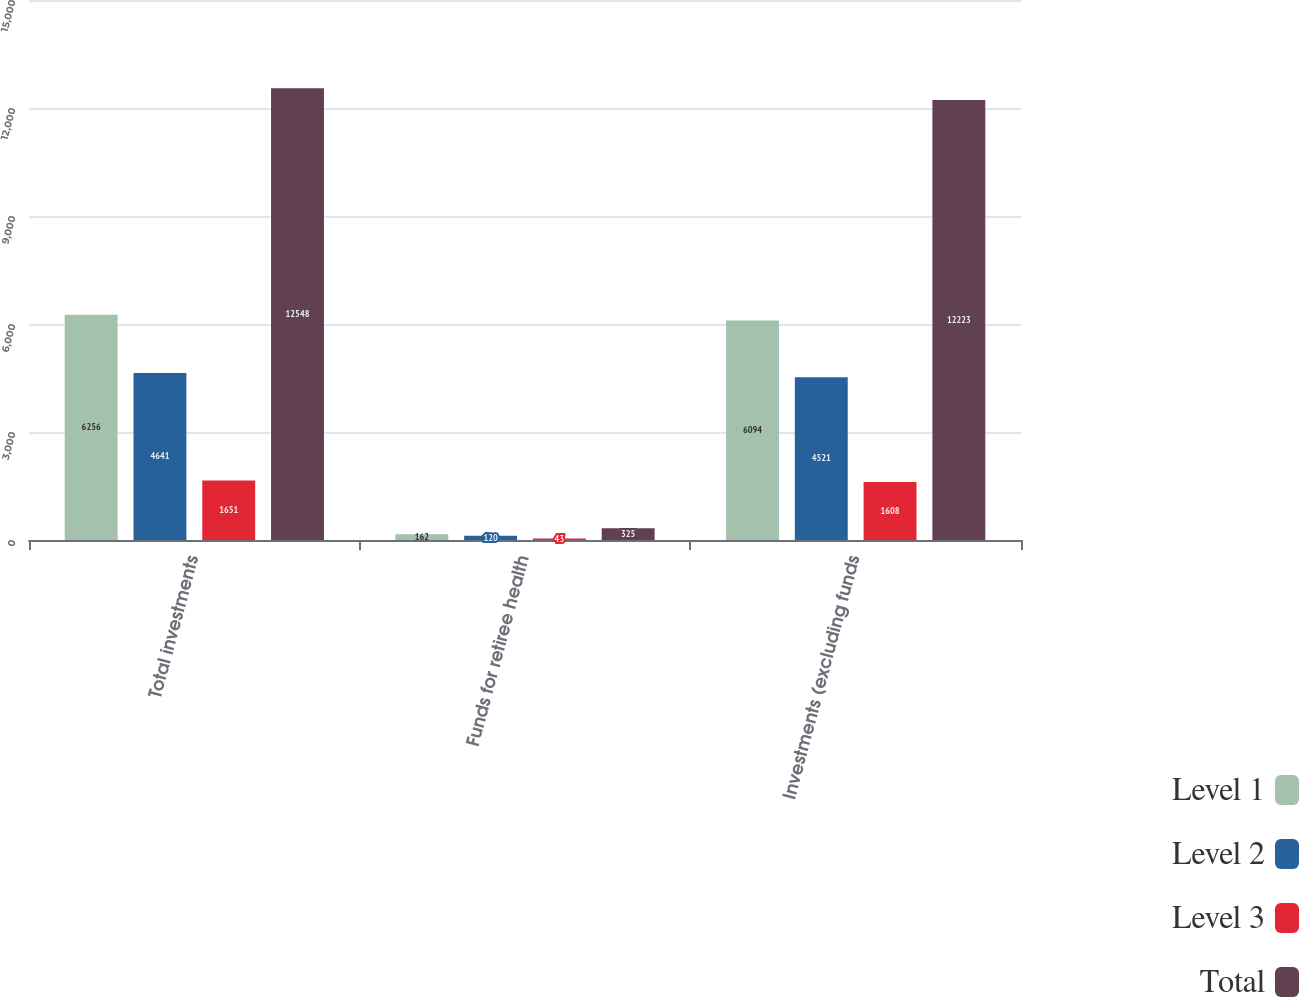<chart> <loc_0><loc_0><loc_500><loc_500><stacked_bar_chart><ecel><fcel>Total investments<fcel>Funds for retiree health<fcel>Investments (excluding funds<nl><fcel>Level 1<fcel>6256<fcel>162<fcel>6094<nl><fcel>Level 2<fcel>4641<fcel>120<fcel>4521<nl><fcel>Level 3<fcel>1651<fcel>43<fcel>1608<nl><fcel>Total<fcel>12548<fcel>325<fcel>12223<nl></chart> 